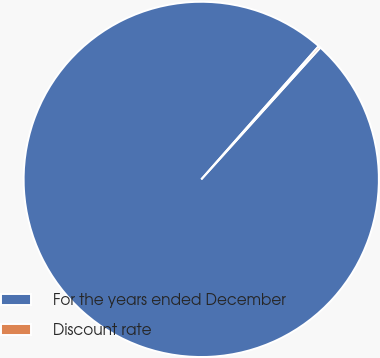Convert chart to OTSL. <chart><loc_0><loc_0><loc_500><loc_500><pie_chart><fcel>For the years ended December<fcel>Discount rate<nl><fcel>99.8%<fcel>0.2%<nl></chart> 